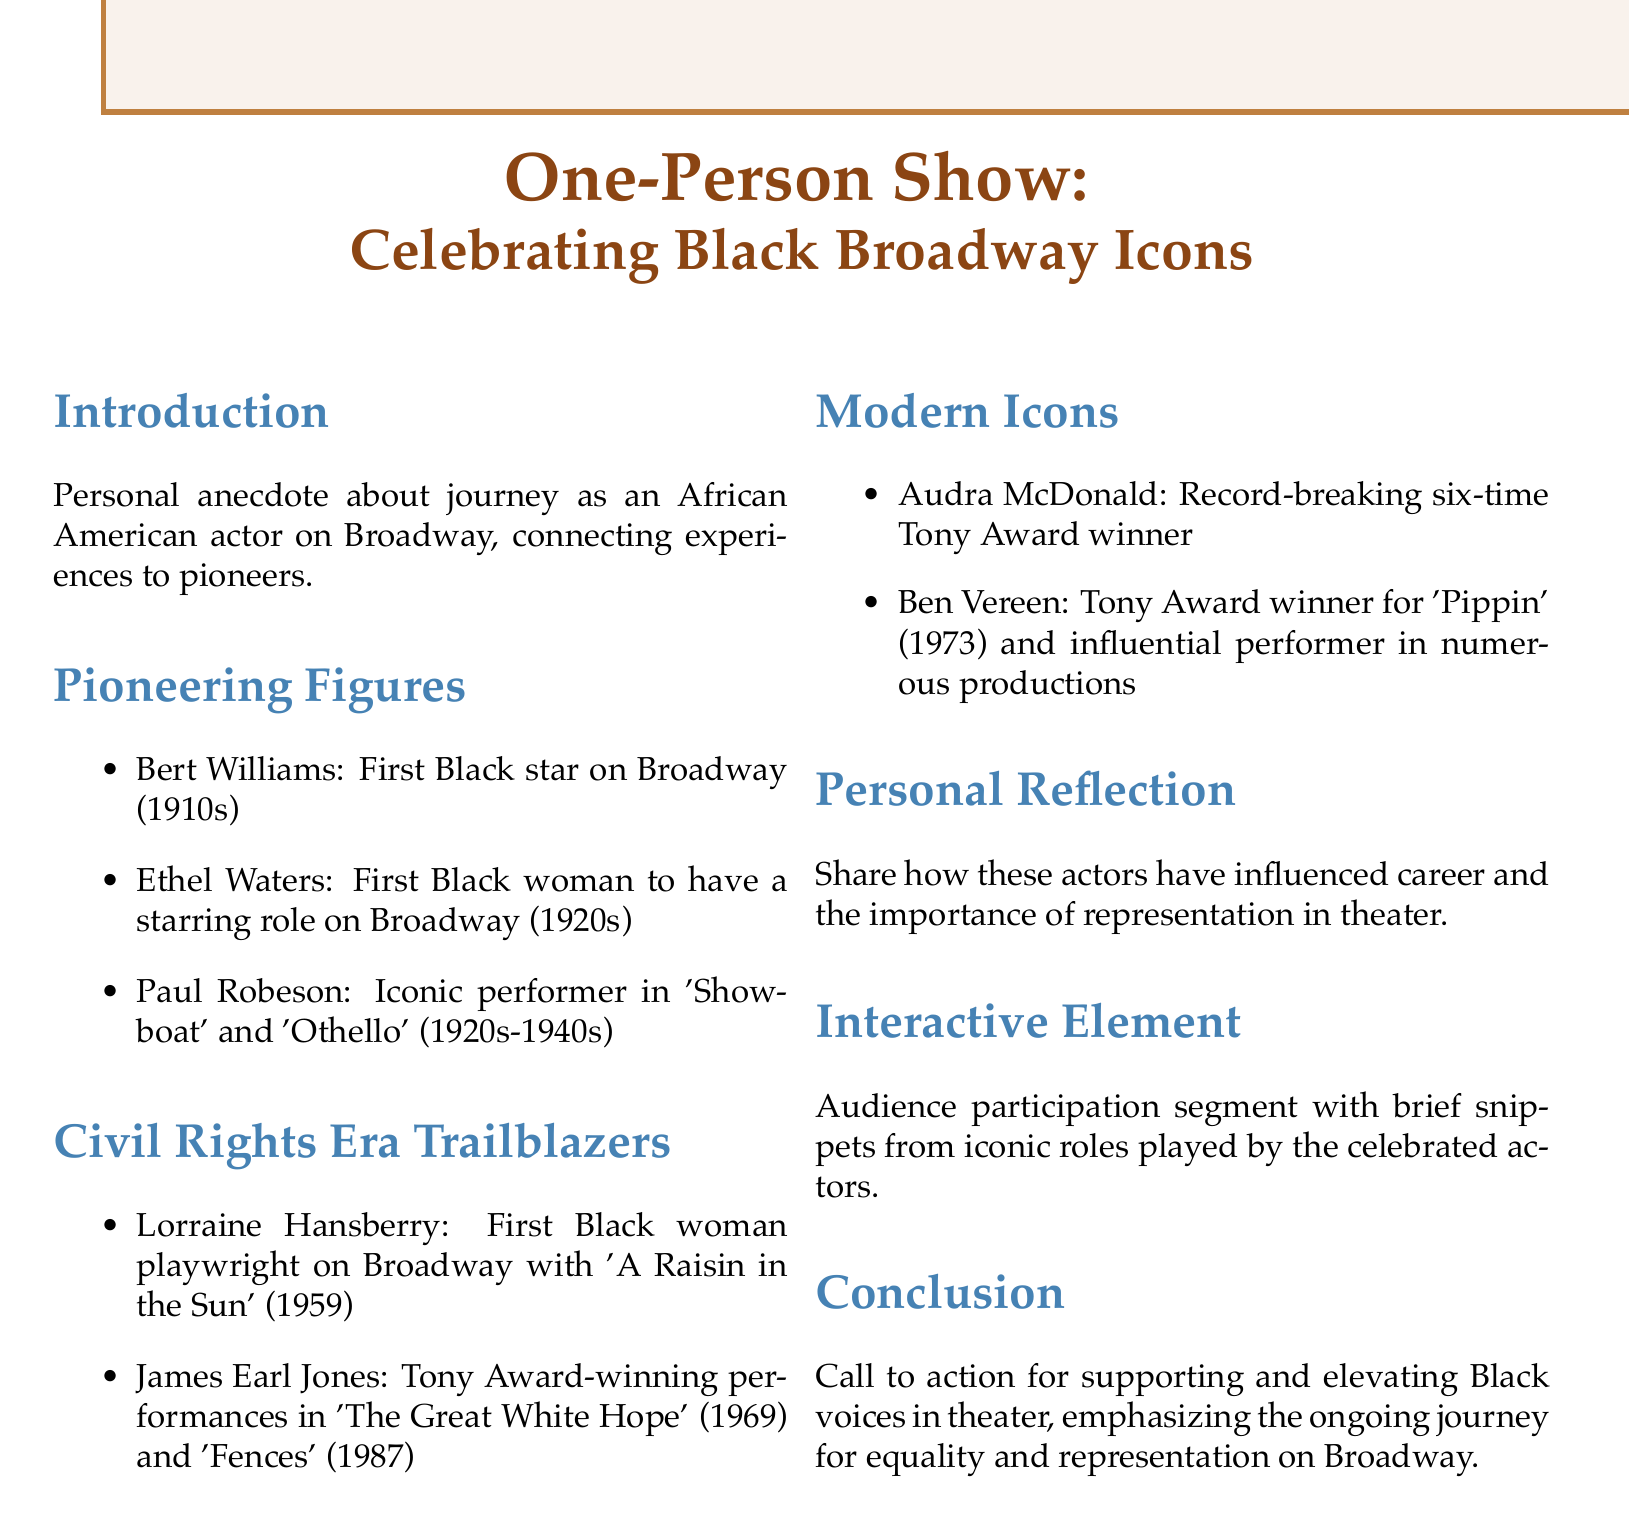What is the title of the show? The title of the show is explicitly stated at the beginning of the document.
Answer: One-Person Show: Celebrating Black Broadway Icons Who was the first Black star on Broadway? Bert Williams is mentioned as the first Black star on Broadway in the Pioneering Figures section.
Answer: Bert Williams What year did Lorraine Hansberry's play premiere? The year of Lorraine Hansberry's play is provided in the Civil Rights Era Trailblazers section.
Answer: 1959 How many Tony Awards has Audra McDonald won? The number of Tony Awards won by Audra McDonald is specified in the Modern Icons section.
Answer: Six Which actor starred in 'Fences'? The actor associated with starring in 'Fences' is mentioned in the Civil Rights Era Trailblazers section.
Answer: James Earl Jones What is the purpose of the Interactive Element? The purpose is explained in the Interactive Element section, highlighting audience participation.
Answer: Audience participation segment What theme does the conclusion emphasize? The conclusion emphasizes a specific theme regarding representation in theater.
Answer: Equality and representation Who is recognized as the first Black woman playwright on Broadway? The document specifically identifies the first Black woman playwright in the Civil Rights Era Trailblazers section.
Answer: Lorraine Hansberry 